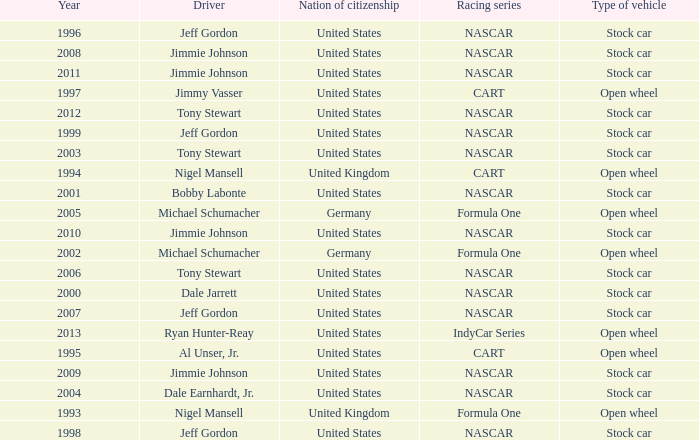What driver has a stock car vehicle with a year of 1999? Jeff Gordon. 